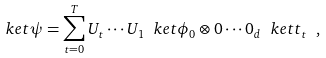Convert formula to latex. <formula><loc_0><loc_0><loc_500><loc_500>\ k e t { \psi } = \sum _ { t = 0 } ^ { T } U _ { t } \cdots U _ { 1 } \ k e t { \phi _ { 0 } \otimes 0 \cdots 0 } _ { d } \ k e t { t } _ { t } \ ,</formula> 